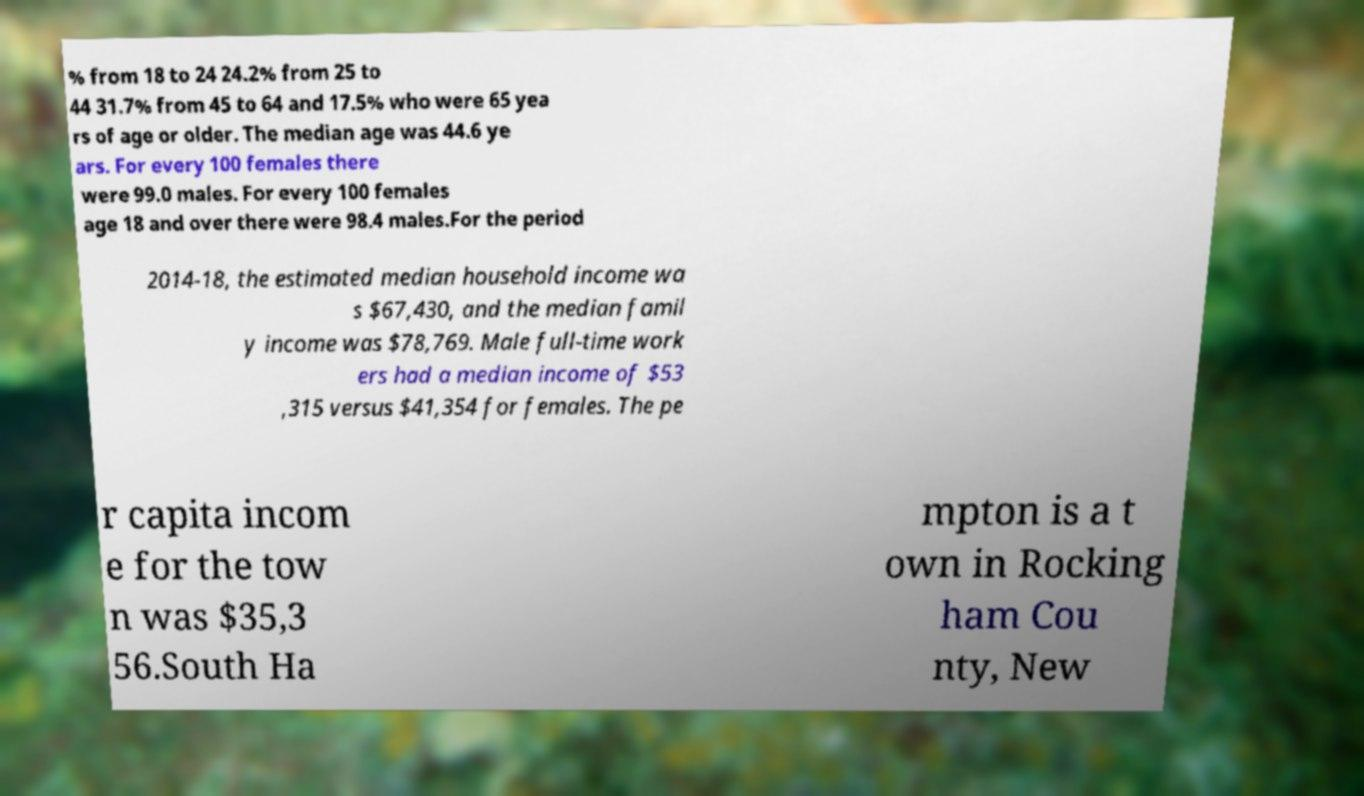Can you read and provide the text displayed in the image?This photo seems to have some interesting text. Can you extract and type it out for me? % from 18 to 24 24.2% from 25 to 44 31.7% from 45 to 64 and 17.5% who were 65 yea rs of age or older. The median age was 44.6 ye ars. For every 100 females there were 99.0 males. For every 100 females age 18 and over there were 98.4 males.For the period 2014-18, the estimated median household income wa s $67,430, and the median famil y income was $78,769. Male full-time work ers had a median income of $53 ,315 versus $41,354 for females. The pe r capita incom e for the tow n was $35,3 56.South Ha mpton is a t own in Rocking ham Cou nty, New 